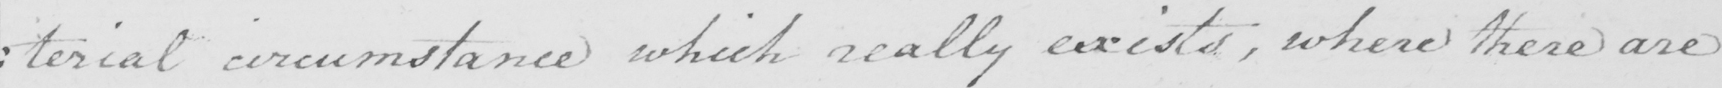What text is written in this handwritten line? : terial circumstance which really exists , where there are 